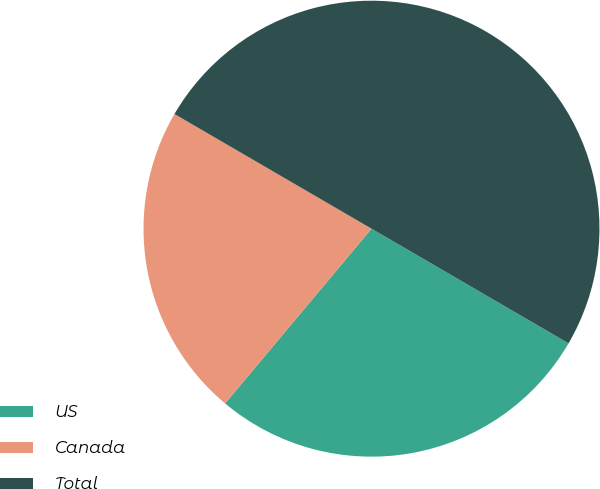<chart> <loc_0><loc_0><loc_500><loc_500><pie_chart><fcel>US<fcel>Canada<fcel>Total<nl><fcel>27.71%<fcel>22.29%<fcel>50.0%<nl></chart> 